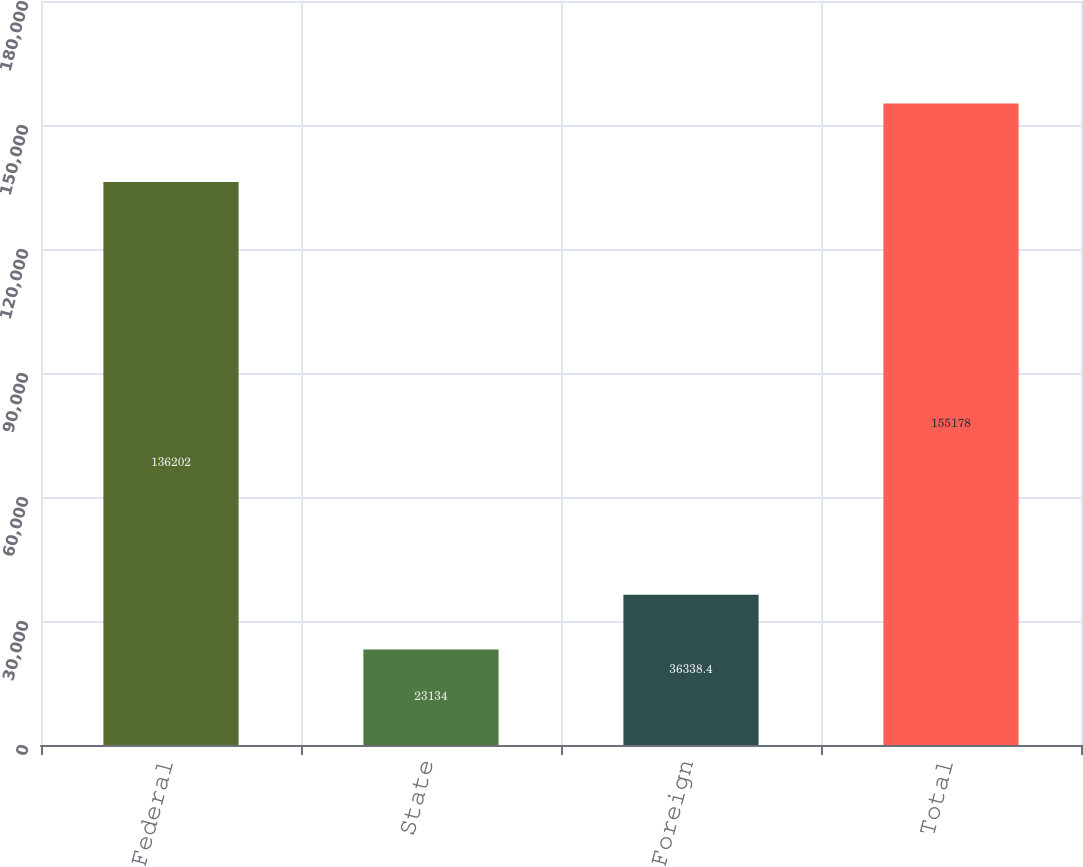Convert chart. <chart><loc_0><loc_0><loc_500><loc_500><bar_chart><fcel>Federal<fcel>State<fcel>Foreign<fcel>Total<nl><fcel>136202<fcel>23134<fcel>36338.4<fcel>155178<nl></chart> 